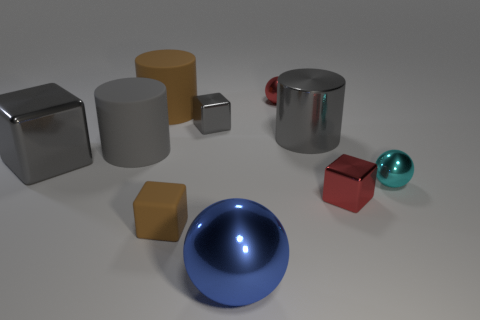What shape is the matte object that is the same size as the brown cylinder? The matte object that matches the brown cylinder in size appears to be a gray cylinder. The color is the main distinguishable attribute, with matte indicating a non-shiny surface, which is a characteristic of the gray cylinder seen in the image. 